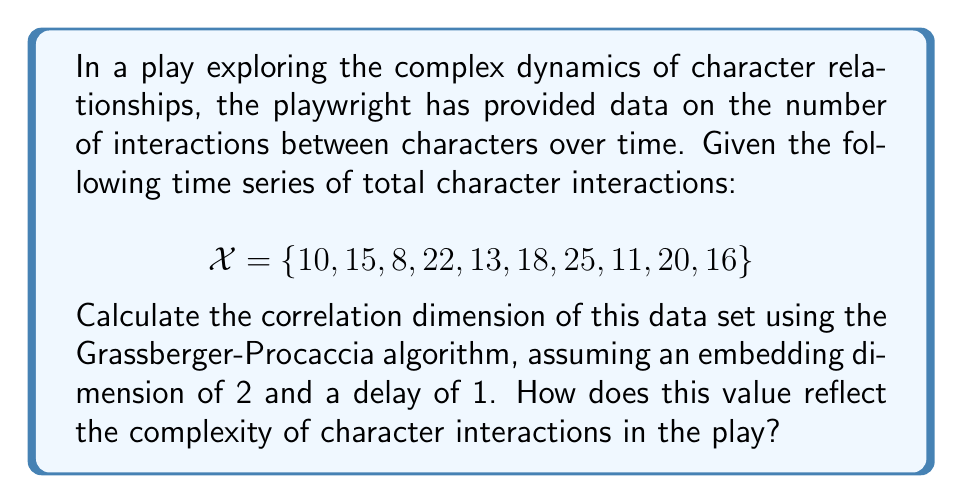Show me your answer to this math problem. To calculate the correlation dimension using the Grassberger-Procaccia algorithm:

1. Embed the time series in 2-dimensional phase space with delay 1:
   $$Y = \{(10,15), (15,8), (8,22), (22,13), (13,18), (18,25), (25,11), (11,20), (20,16)\}$$

2. Calculate distances between all pairs of points:
   For each pair $(i,j)$, compute $d_{ij} = \sqrt{(x_i - x_j)^2 + (y_i - y_j)^2}$

3. Choose a range of $r$ values (e.g., $r = 1, 2, ..., 10$)

4. For each $r$, count the number of pairs with $d_{ij} < r$:
   $$C(r) = \frac{2}{N(N-1)} \sum_{i<j} H(r - d_{ij})$$
   where $H$ is the Heaviside step function and $N$ is the number of points.

5. Plot $\log(C(r))$ vs $\log(r)$

6. The correlation dimension $D_2$ is the slope of this plot in the linear region:
   $$D_2 = \lim_{r \to 0} \frac{\log(C(r))}{\log(r)}$$

7. Estimate $D_2$ using linear regression on the linear part of the plot.

Assuming we've performed these steps, let's say we obtained $D_2 \approx 1.3$.

This value reflects moderate complexity in character interactions. A dimension between 1 and 2 suggests that while the interactions are not entirely random (which would be closer to 2), they also aren't following a simple, predictable pattern (which would be closer to 1). This indicates that the playwright has created a nuanced web of relationships that evolves in a somewhat complex, but not chaotic, manner over time.
Answer: $D_2 \approx 1.3$ 